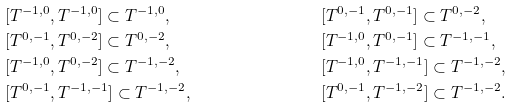Convert formula to latex. <formula><loc_0><loc_0><loc_500><loc_500>& [ T ^ { - 1 , 0 } , T ^ { - 1 , 0 } ] \subset T ^ { - 1 , 0 } , & & [ T ^ { 0 , - 1 } , T ^ { 0 , - 1 } ] \subset T ^ { 0 , - 2 } , & \\ & [ T ^ { 0 , - 1 } , T ^ { 0 , - 2 } ] \subset T ^ { 0 , - 2 } , & & [ T ^ { - 1 , 0 } , T ^ { 0 , - 1 } ] \subset T ^ { - 1 , - 1 } , & \\ & [ T ^ { - 1 , 0 } , T ^ { 0 , - 2 } ] \subset T ^ { - 1 , - 2 } , & & [ T ^ { - 1 , 0 } , T ^ { - 1 , - 1 } ] \subset T ^ { - 1 , - 2 } , & \\ & [ T ^ { 0 , - 1 } , T ^ { - 1 , - 1 } ] \subset T ^ { - 1 , - 2 } , & & [ T ^ { 0 , - 1 } , T ^ { - 1 , - 2 } ] \subset T ^ { - 1 , - 2 } . &</formula> 